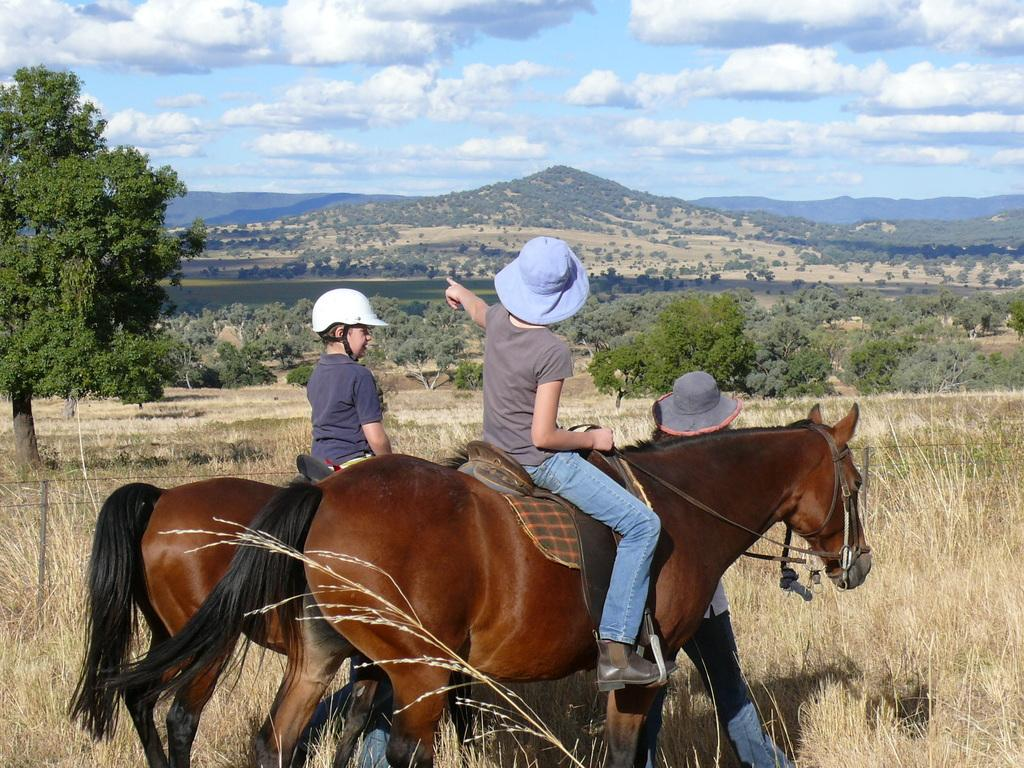How many people are in the image? There are people in the image. What are two of the people doing in the image? Two people are sitting on horses in the image. What can be seen in the background of the image? There are trees and the sky visible in the background of the image. What type of butter is being used to grease the cave in the image? There is no cave or butter present in the image. 